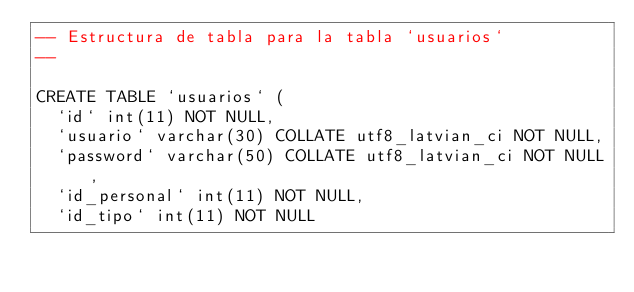Convert code to text. <code><loc_0><loc_0><loc_500><loc_500><_SQL_>-- Estructura de tabla para la tabla `usuarios`
--

CREATE TABLE `usuarios` (
  `id` int(11) NOT NULL,
  `usuario` varchar(30) COLLATE utf8_latvian_ci NOT NULL,
  `password` varchar(50) COLLATE utf8_latvian_ci NOT NULL,
  `id_personal` int(11) NOT NULL,
  `id_tipo` int(11) NOT NULL</code> 